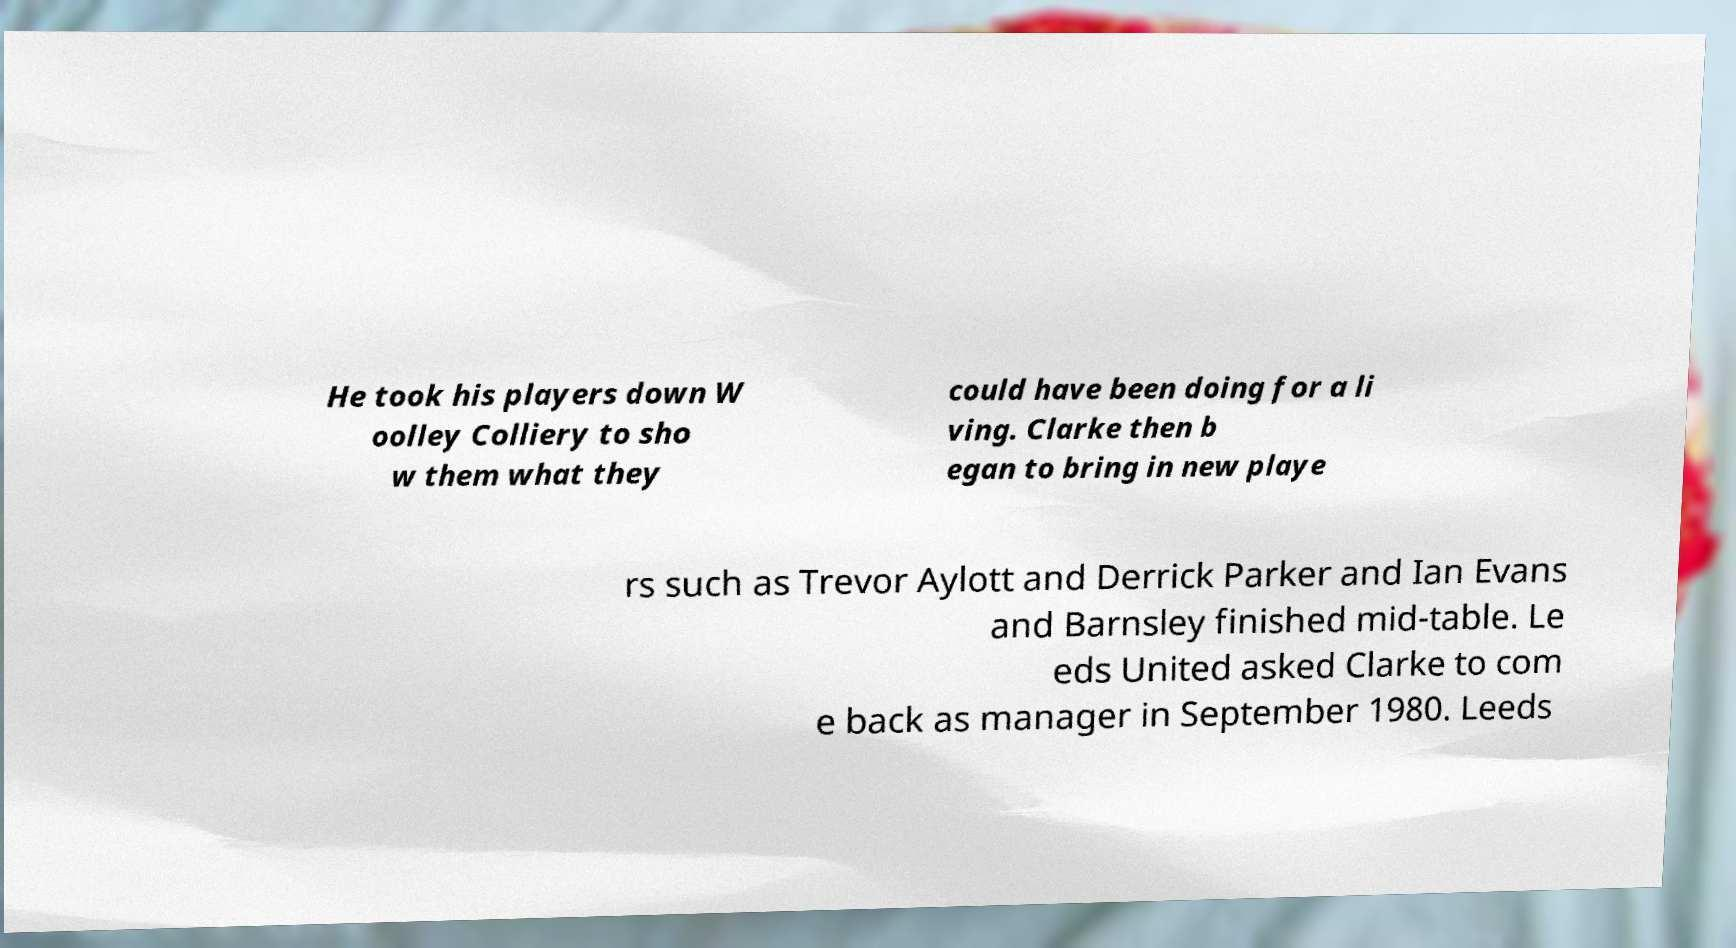There's text embedded in this image that I need extracted. Can you transcribe it verbatim? He took his players down W oolley Colliery to sho w them what they could have been doing for a li ving. Clarke then b egan to bring in new playe rs such as Trevor Aylott and Derrick Parker and Ian Evans and Barnsley finished mid-table. Le eds United asked Clarke to com e back as manager in September 1980. Leeds 